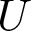Convert formula to latex. <formula><loc_0><loc_0><loc_500><loc_500>U</formula> 